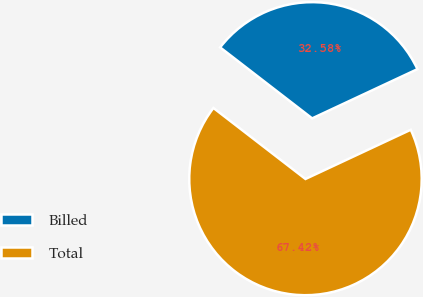Convert chart to OTSL. <chart><loc_0><loc_0><loc_500><loc_500><pie_chart><fcel>Billed<fcel>Total<nl><fcel>32.58%<fcel>67.42%<nl></chart> 